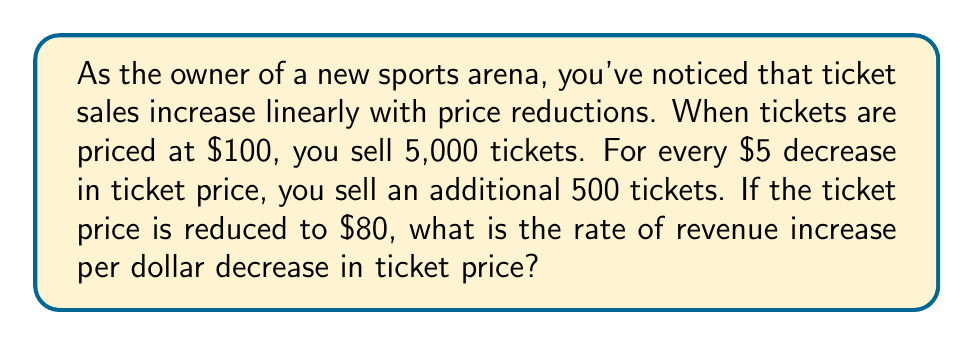Could you help me with this problem? Let's approach this step-by-step:

1) First, let's define our variables:
   $p$ = ticket price
   $q$ = quantity of tickets sold
   $R$ = revenue

2) We're given that when $p = 100$, $q = 5,000$
   And for every $5 decrease in $p$, $q$ increases by 500

3) We can express this relationship as:
   $q = 5000 + 500 \cdot \frac{100-p}{5} = 5000 + 100(100-p)$

4) Revenue is price times quantity:
   $R = pq = p(5000 + 100(100-p)) = 500p + 10000p - 100p^2$

5) To find the rate of revenue increase, we need to find $\frac{dR}{dp}$:
   $$\frac{dR}{dp} = 500 + 10000 - 200p$$

6) The question asks for the rate when $p = 80$:
   $$\frac{dR}{dp}|_{p=80} = 500 + 10000 - 200(80) = -5500$$

7) This negative value indicates that revenue is decreasing as price increases.
   To find the rate of increase per dollar decrease, we need to negate this:
   $5500 per dollar decrease in ticket price
Answer: $5500 per dollar decrease in ticket price 